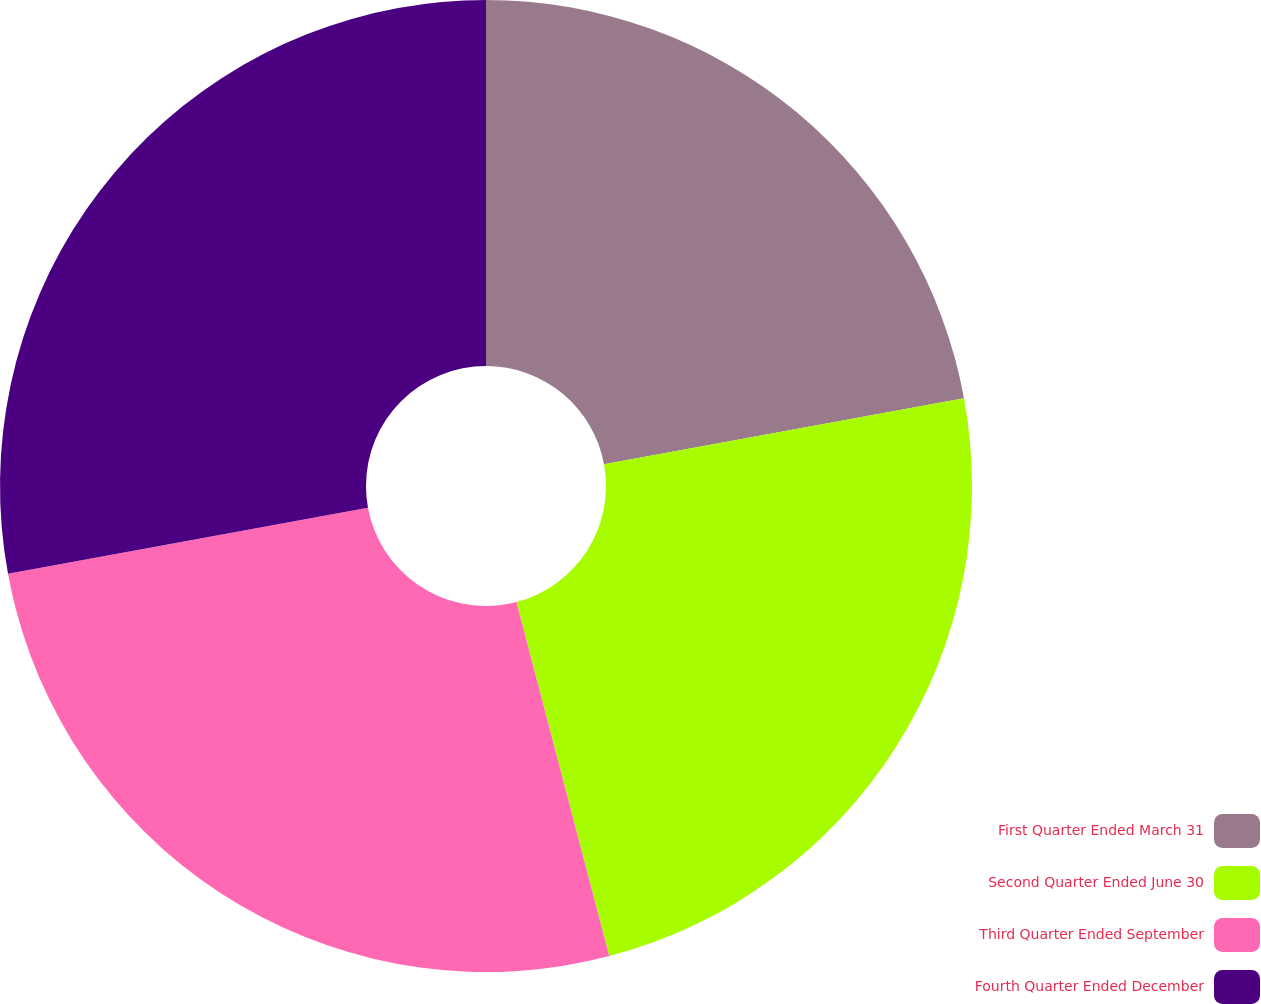<chart> <loc_0><loc_0><loc_500><loc_500><pie_chart><fcel>First Quarter Ended March 31<fcel>Second Quarter Ended June 30<fcel>Third Quarter Ended September<fcel>Fourth Quarter Ended December<nl><fcel>22.11%<fcel>23.81%<fcel>26.19%<fcel>27.89%<nl></chart> 